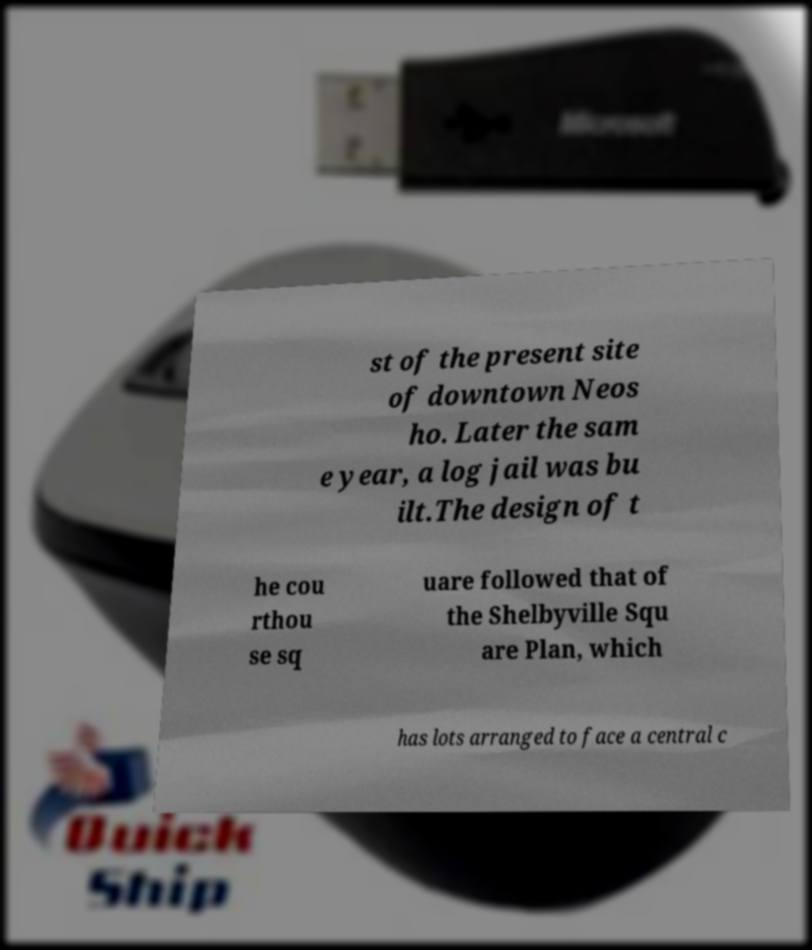Could you extract and type out the text from this image? st of the present site of downtown Neos ho. Later the sam e year, a log jail was bu ilt.The design of t he cou rthou se sq uare followed that of the Shelbyville Squ are Plan, which has lots arranged to face a central c 